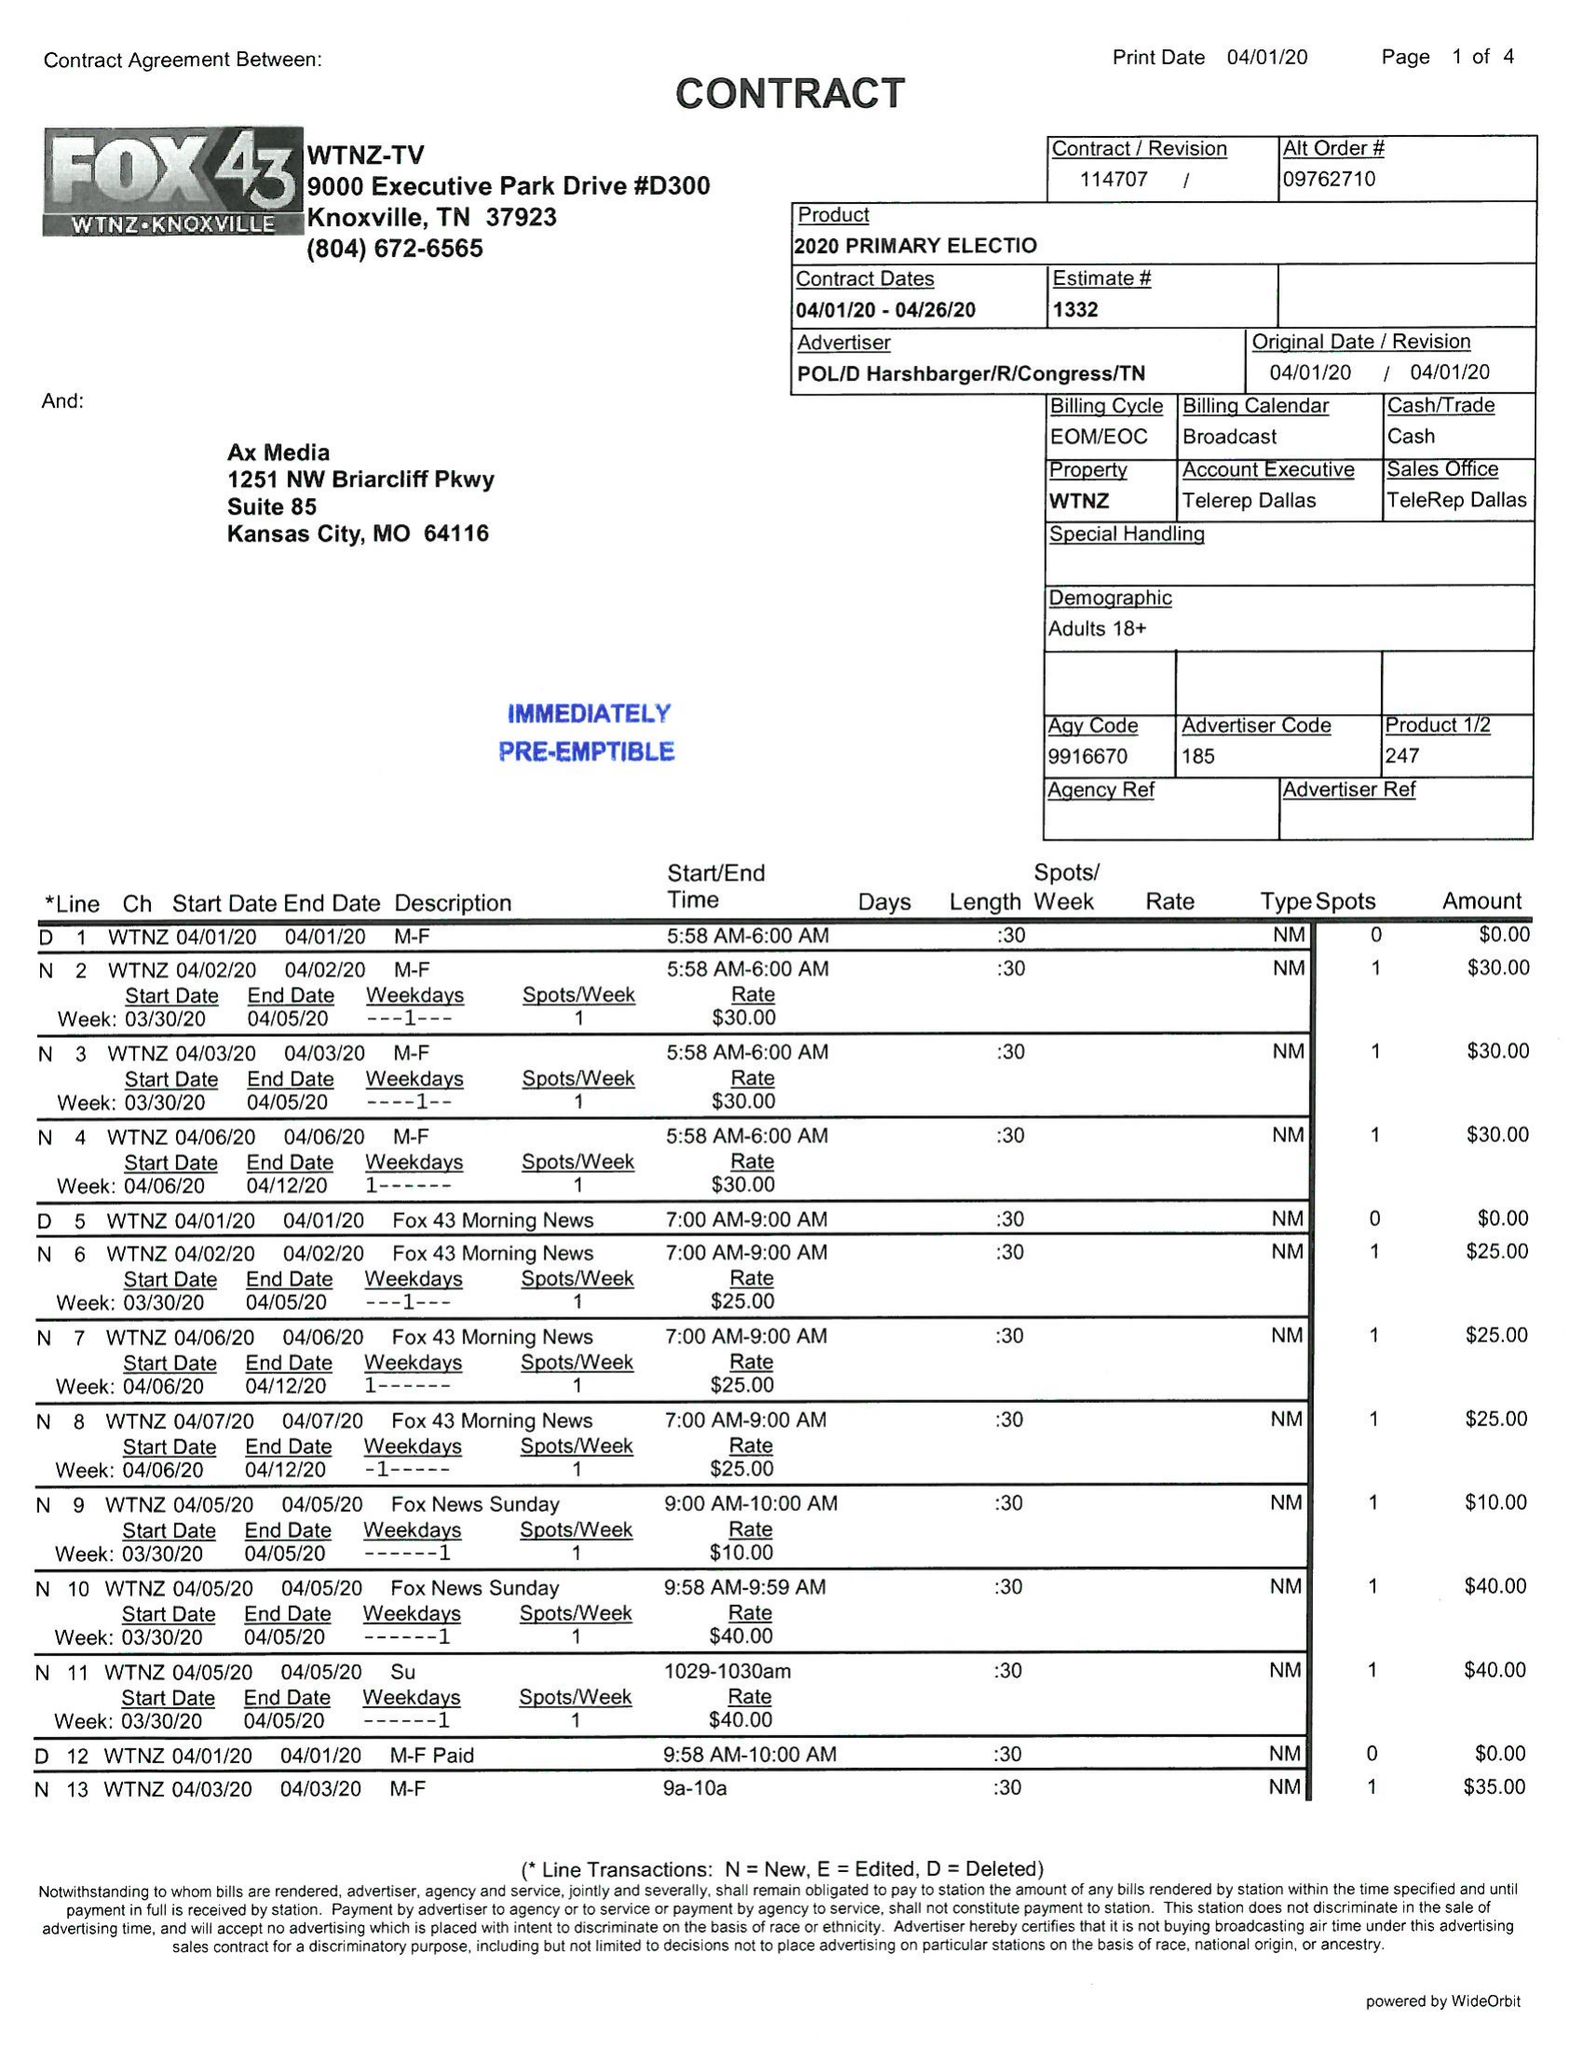What is the value for the gross_amount?
Answer the question using a single word or phrase. 1590.00 